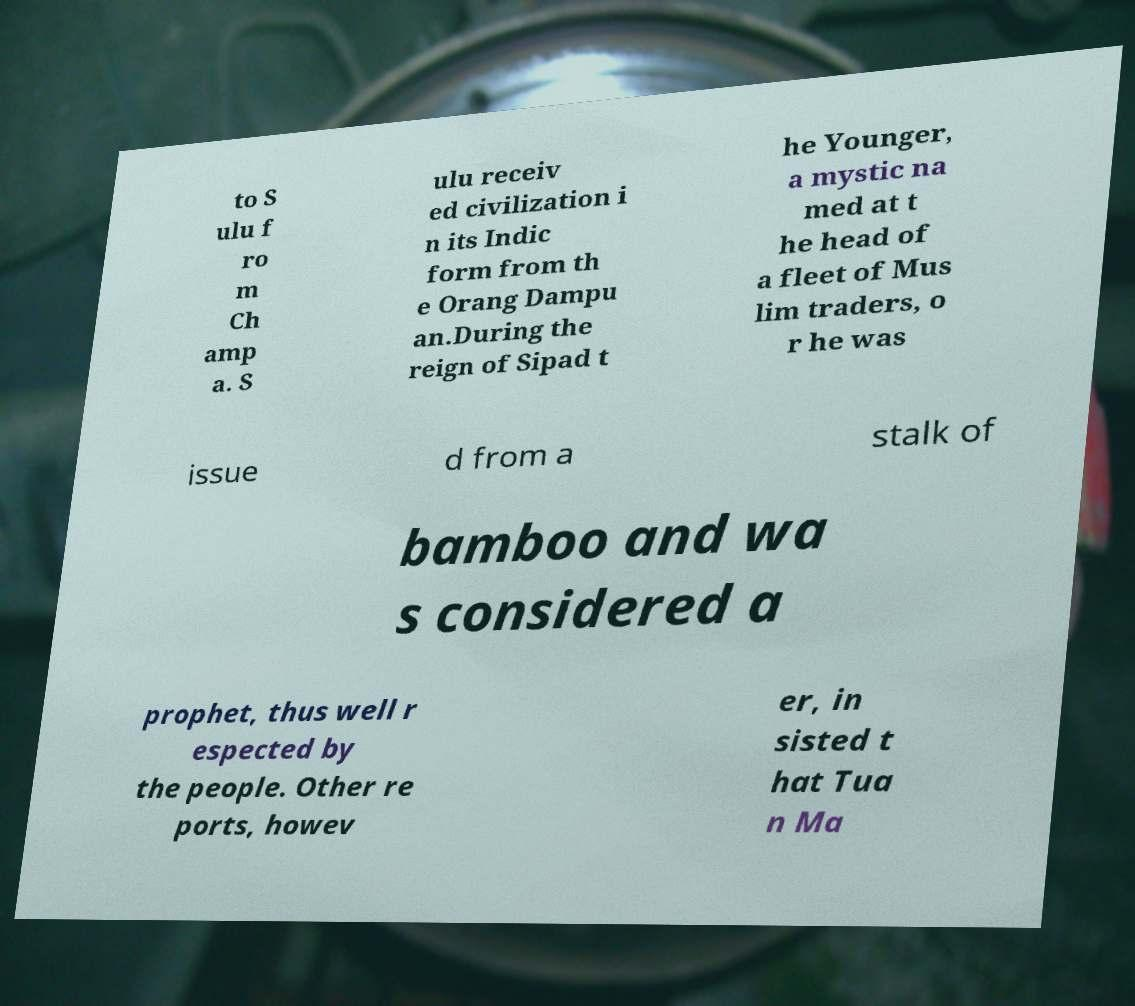What messages or text are displayed in this image? I need them in a readable, typed format. to S ulu f ro m Ch amp a. S ulu receiv ed civilization i n its Indic form from th e Orang Dampu an.During the reign of Sipad t he Younger, a mystic na med at t he head of a fleet of Mus lim traders, o r he was issue d from a stalk of bamboo and wa s considered a prophet, thus well r espected by the people. Other re ports, howev er, in sisted t hat Tua n Ma 